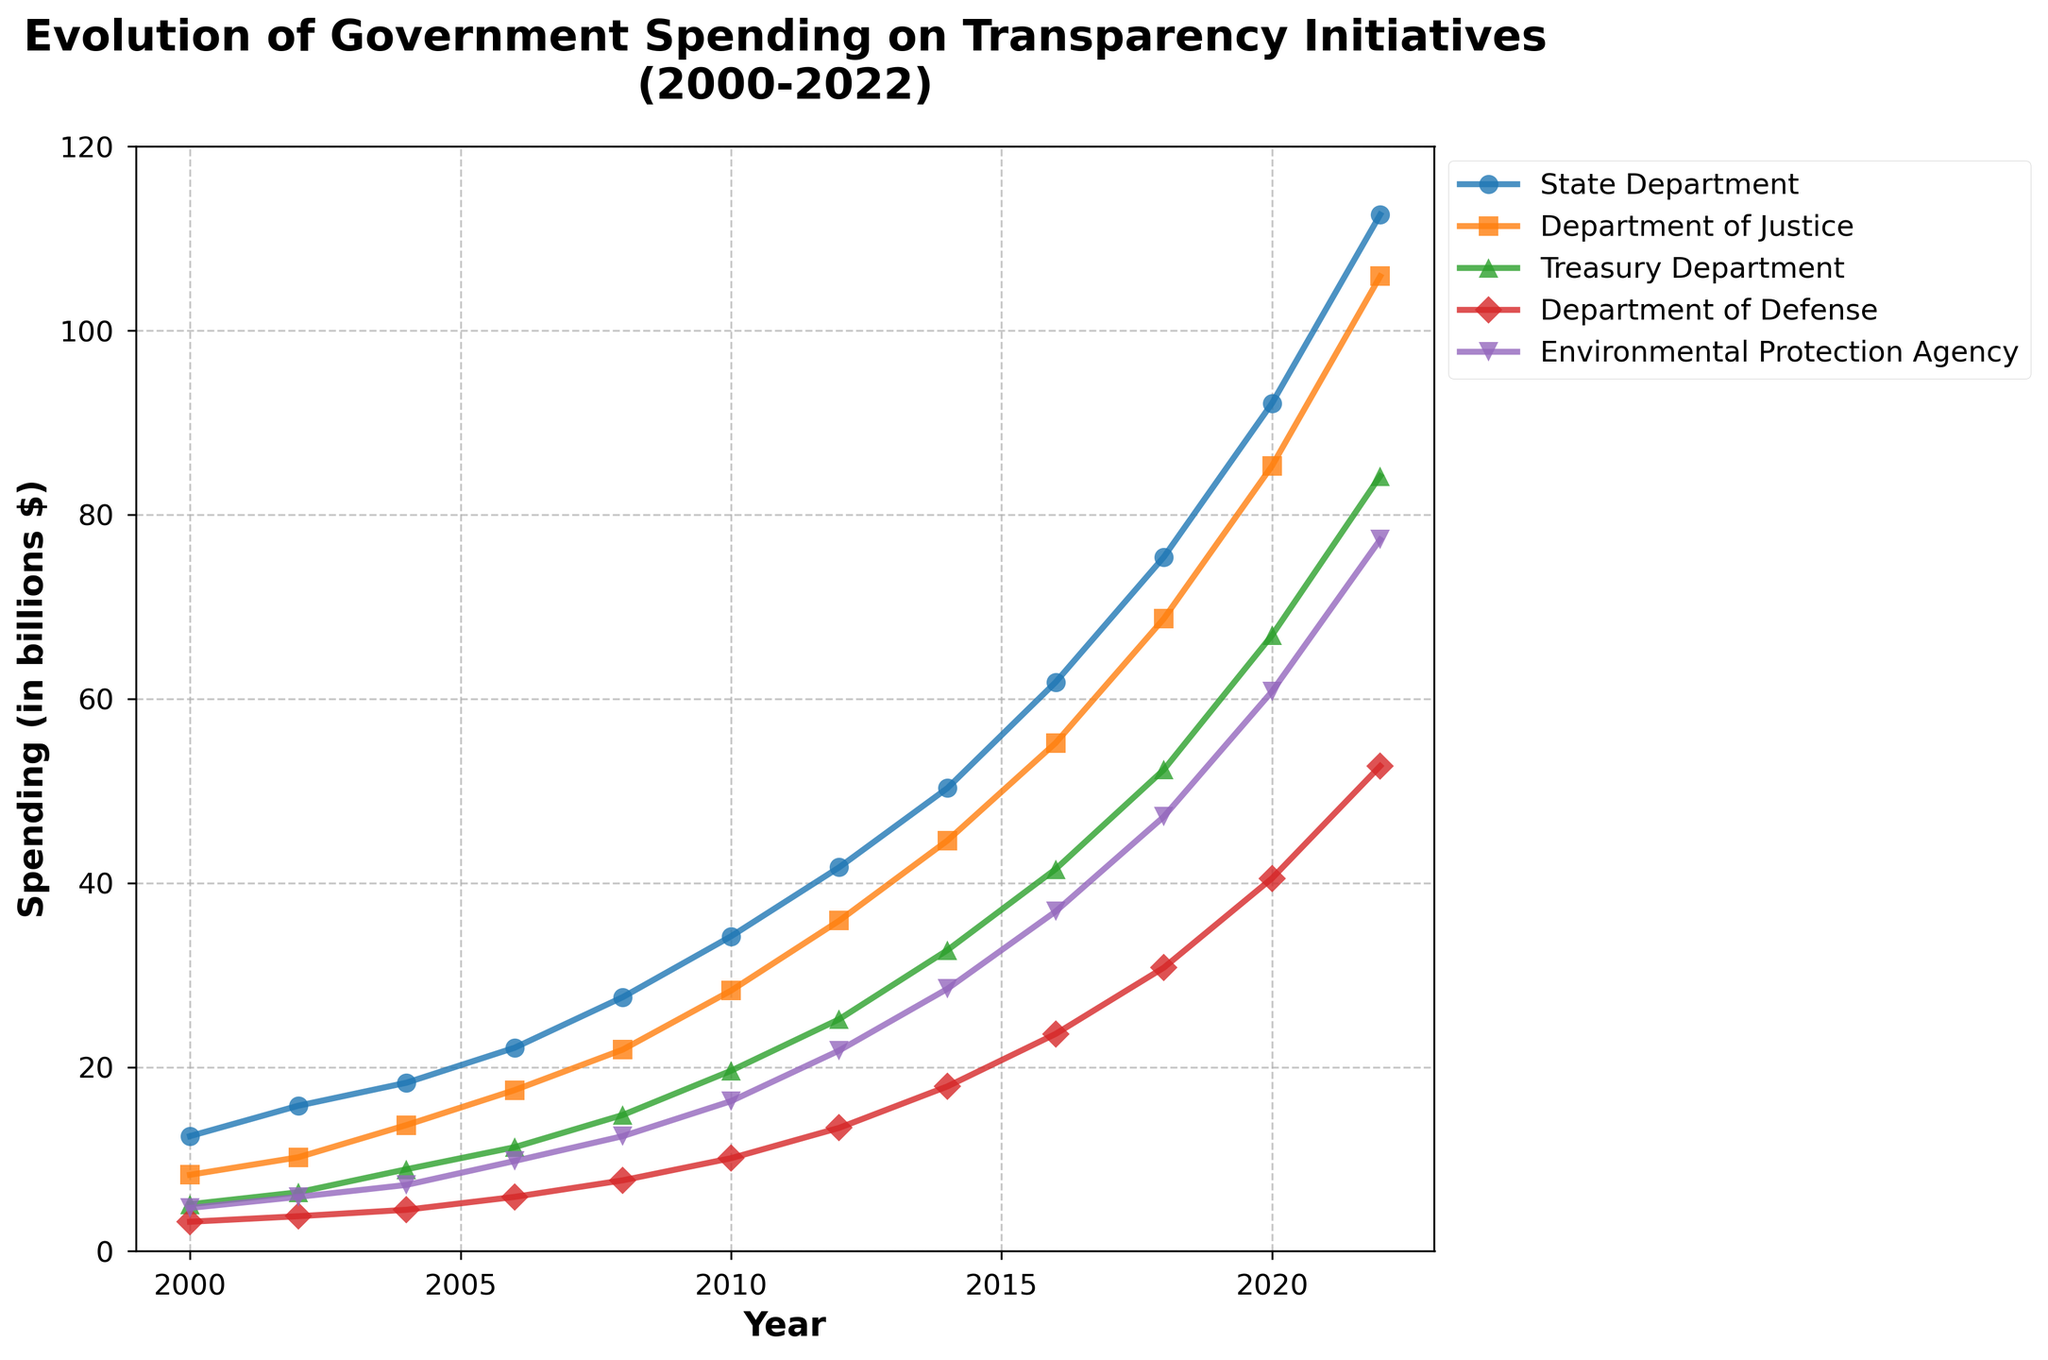What was the spending on transparency initiatives by the State Department in 2010? Look for the 2010 data point under the State Department line.
Answer: 34.2 billion $ Which department had the highest spending on transparency in 2022, and what was the amount? Compare the 2022 data points for all departments and find the highest value.
Answer: State Department, 112.6 billion $ Between which two consecutive years did the Department of Defense see the highest increase in spending? Calculate the differences in spending between consecutive years for the Department of Defense. The largest difference indicates the highest increase.
Answer: 2018 to 2020, 9.7 billion $ What is the average annual spending on transparency initiatives by the Environmental Protection Agency from 2000 to 2022? Sum the EPA spending figures from each year between 2000 and 2022, then divide by the number of years (12).
Answer: 22.48 billion $ In which year did the Treasury Department's spending on transparency first exceed 50 billion $? Find the first year in which the Treasury Department's spending is greater than 50 billion $.
Answer: 2018 How did spending on transparency initiatives change for the Department of Justice from 2004 to 2022? Calculate the difference in the Department of Justice's spending between 2004 and 2022.
Answer: Increased by 92.2 billion $ Which department had the lowest spending on transparency initiatives in 2004, and what was the amount? Compare the 2004 data points for all departments and find the smallest value.
Answer: Department of Defense, 4.5 billion $ By how much did the State Department's spending on transparency initiatives increase from 2018 to 2022? Subtract the 2018 spending value from the 2022 value for the State Department.
Answer: Increased by 37.2 billion $ Compare the spending of the Environmental Protection Agency and the Treasury Department in 2016. Which one was higher, and by how much? Subtract the EPA's 2016 spending from the Treasury Department's 2016 spending to find the difference.
Answer: Treasury Department, by 4.6 billion $ What was the percentage increase in spending on transparency initiatives by the Department of Justice from 2000 to 2022? Calculate the percentage increase: ((2022 value - 2000 value) / 2000 value) * 100.
Answer: 1176.83% 